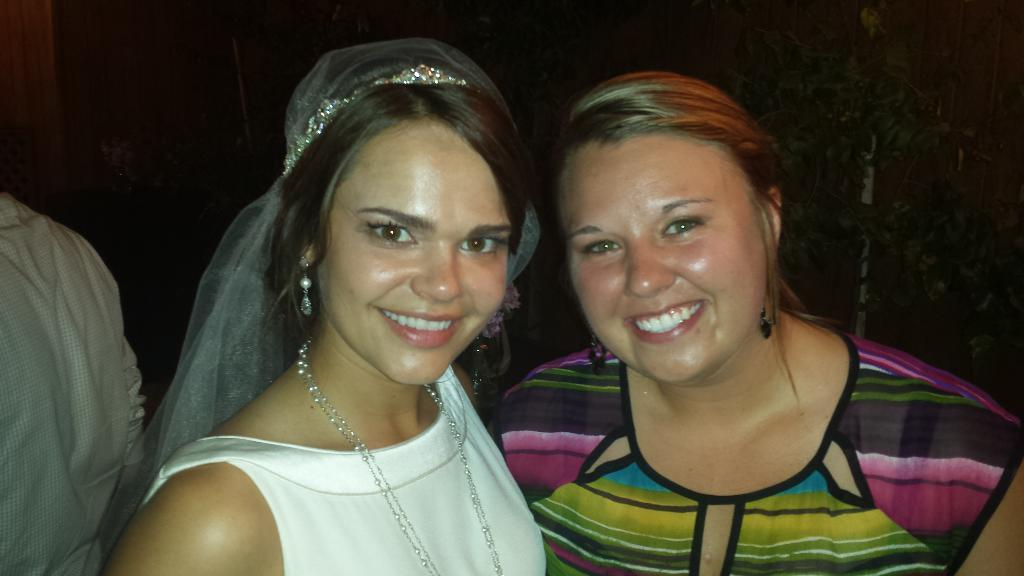How many women are in the image? There are two women in the image. What expression do the women have? The women are smiling. Can you describe the person beside the women? Unfortunately, the provided facts do not mention any details about the person beside the women. What type of vegetation is visible in the image? Leaves are visible in the image. How would you describe the lighting in the image? The background of the image is dark. What type of trouble is the fifth person experiencing in the image? There is no mention of a fifth person in the image, so it is impossible to determine if they are experiencing any trouble. 